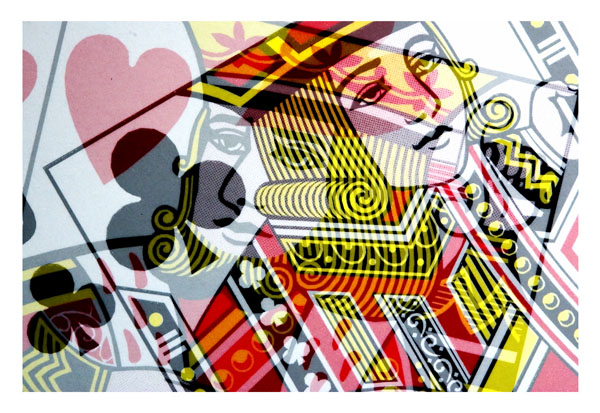What kind of artistic style or influence does the playing card's design seem to have? The playing card's design appears to be influenced by a modern, abstract artistic style. There are elements of cubism reflected in the fragmented and geometric shaping of the facial features and surrounding details. This gives the card a dynamic and contemporary look. 